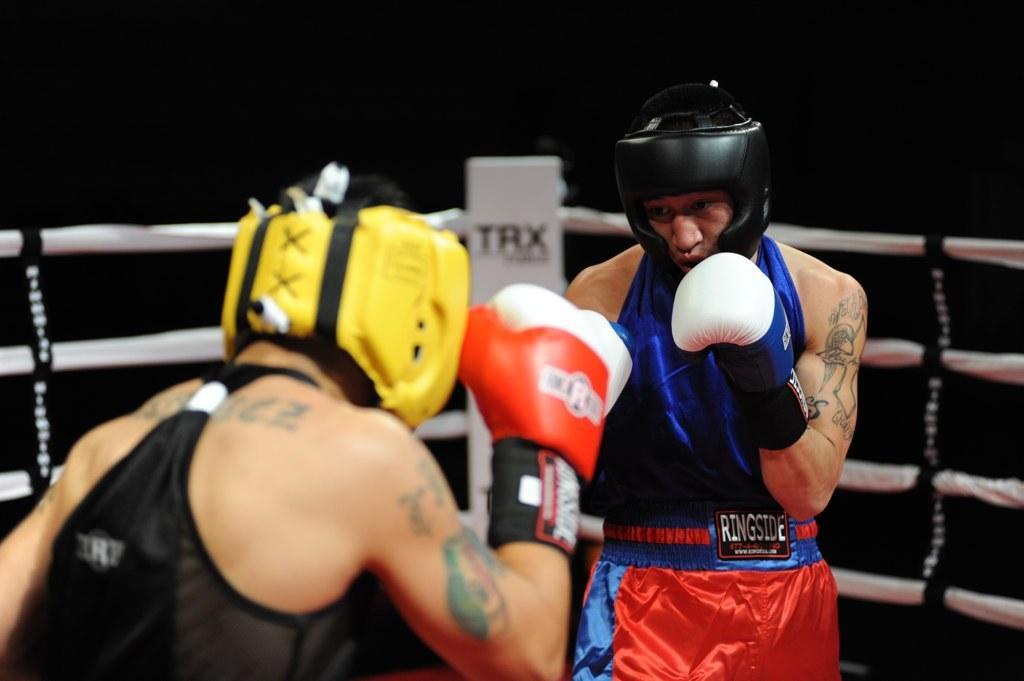In one or two sentences, can you explain what this image depicts? In this image I can see two people are standing and wearing different color dresses, helmets and gloves. I can see the boxing-ring and the black color background. 